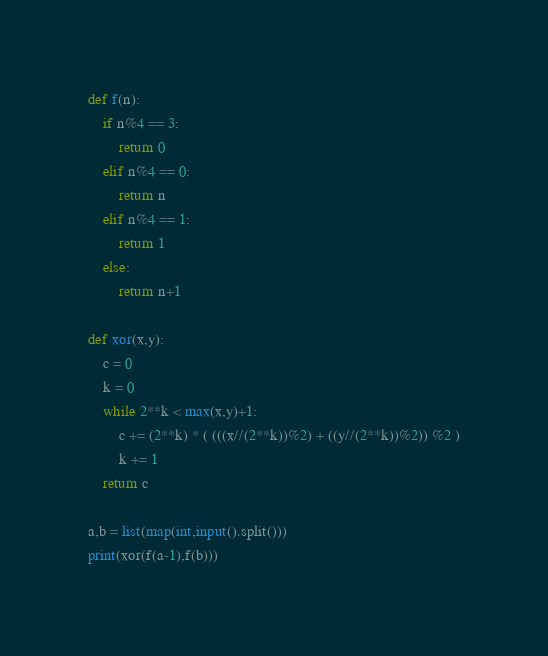Convert code to text. <code><loc_0><loc_0><loc_500><loc_500><_Python_>def f(n):
	if n%4 == 3:
		return 0
	elif n%4 == 0:
		return n
	elif n%4 == 1:
		return 1
	else:
		return n+1

def xor(x,y):
	c = 0
	k = 0
	while 2**k < max(x,y)+1:
		c += (2**k) * ( (((x//(2**k))%2) + ((y//(2**k))%2)) %2 )
		k += 1
	return c

a,b = list(map(int,input().split()))
print(xor(f(a-1),f(b)))</code> 